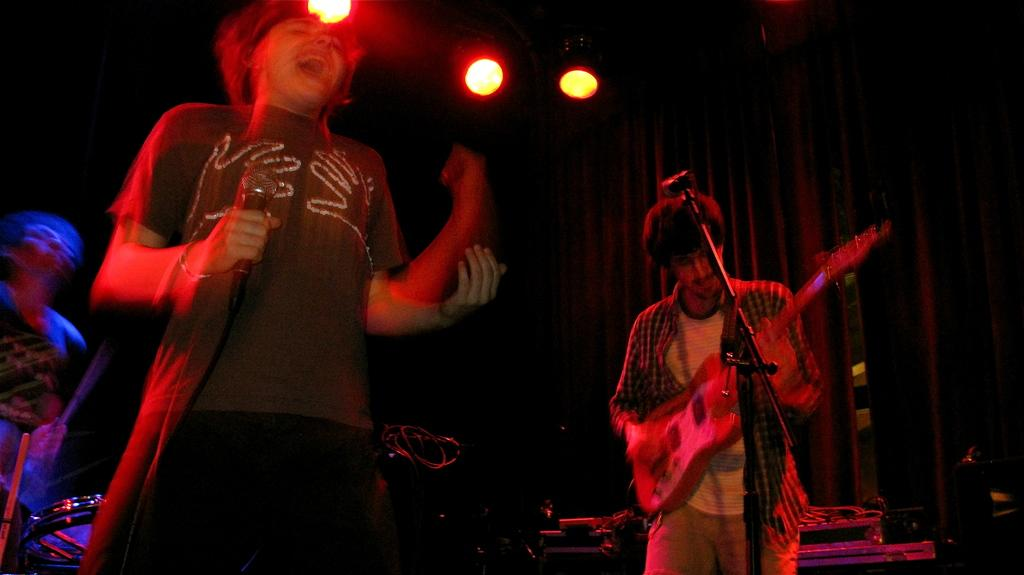What are the people in the middle of the image doing? The people are standing in the middle of the image and holding musical instruments. What object is used for amplifying sound in the image? A microphone is present in the image. What can be seen in the background of the image? Cloth is visible in the background. What is illuminating the scene in the image? Lights are visible at the top of the image. What type of food is being served on a plate in the image? There is no plate or food present in the image. What type of tail can be seen on one of the people in the image? There are no tails visible on any of the people in the image. 